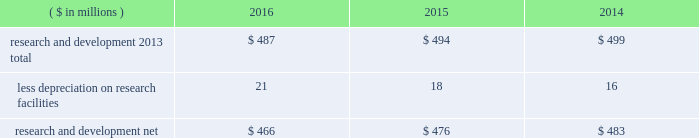Notes to the consolidated financial statements 40 2016 ppg annual report and form 10-k 1 .
Summary of significant accounting policies principles of consolidation the accompanying consolidated financial statements include the accounts of ppg industries , inc .
( 201cppg 201d or the 201ccompany 201d ) and all subsidiaries , both u.s .
And non-u.s. , that it controls .
Ppg owns more than 50% ( 50 % ) of the voting stock of most of the subsidiaries that it controls .
For those consolidated subsidiaries in which the company 2019s ownership is less than 100% ( 100 % ) , the outside shareholders 2019 interests are shown as noncontrolling interests .
Investments in companies in which ppg owns 20% ( 20 % ) to 50% ( 50 % ) of the voting stock and has the ability to exercise significant influence over operating and financial policies of the investee are accounted for using the equity method of accounting .
As a result , ppg 2019s share of the earnings or losses of such equity affiliates is included in the accompanying consolidated statement of income and ppg 2019s share of these companies 2019 shareholders 2019 equity is included in 201cinvestments 201d in the accompanying consolidated balance sheet .
Transactions between ppg and its subsidiaries are eliminated in consolidation .
Use of estimates in the preparation of financial statements the preparation of financial statements in conformity with u.s .
Generally accepted accounting principles requires management to make estimates and assumptions that affect the reported amounts of assets and liabilities and the disclosure of contingent assets and liabilities at the date of the financial statements , as well as the reported amounts of income and expenses during the reporting period .
Such estimates also include the fair value of assets acquired and liabilities assumed resulting from the allocation of the purchase price related to business combinations consummated .
Actual outcomes could differ from those estimates .
Revenue recognition the company recognizes revenue when the earnings process is complete .
Revenue is recognized by all operating segments when goods are shipped and title to inventory and risk of loss passes to the customer or when services have been rendered .
Shipping and handling costs amounts billed to customers for shipping and handling are reported in 201cnet sales 201d in the accompanying consolidated statement of income .
Shipping and handling costs incurred by the company for the delivery of goods to customers are included in 201ccost of sales , exclusive of depreciation and amortization 201d in the accompanying consolidated statement of income .
Selling , general and administrative costs amounts presented as 201cselling , general and administrative 201d in the accompanying consolidated statement of income are comprised of selling , customer service , distribution and advertising costs , as well as the costs of providing corporate- wide functional support in such areas as finance , law , human resources and planning .
Distribution costs pertain to the movement and storage of finished goods inventory at company- owned and leased warehouses and other distribution facilities .
Advertising costs advertising costs are expensed as incurred and totaled $ 322 million , $ 324 million and $ 297 million in 2016 , 2015 and 2014 , respectively .
Research and development research and development costs , which consist primarily of employee related costs , are charged to expense as incurred. .
Legal costs legal costs , primarily include costs associated with acquisition and divestiture transactions , general litigation , environmental regulation compliance , patent and trademark protection and other general corporate purposes , are charged to expense as incurred .
Foreign currency translation the functional currency of most significant non-u.s .
Operations is their local currency .
Assets and liabilities of those operations are translated into u.s .
Dollars using year-end exchange rates ; income and expenses are translated using the average exchange rates for the reporting period .
Unrealized foreign currency translation adjustments are deferred in accumulated other comprehensive loss , a separate component of shareholders 2019 equity .
Cash equivalents cash equivalents are highly liquid investments ( valued at cost , which approximates fair value ) acquired with an original maturity of three months or less .
Short-term investments short-term investments are highly liquid , high credit quality investments ( valued at cost plus accrued interest ) that have stated maturities of greater than three months to one year .
The purchases and sales of these investments are classified as investing activities in the consolidated statement of cash flows .
Marketable equity securities the company 2019s investment in marketable equity securities is recorded at fair market value and reported in 201cother current assets 201d and 201cinvestments 201d in the accompanying consolidated balance sheet with changes in fair market value recorded in income for those securities designated as trading securities and in other comprehensive income , net of tax , for those designated as available for sale securities. .
What was the percentage change in research and development net from 2015 to 2016? 
Computations: ((466 - 476) / 476)
Answer: -0.02101. 